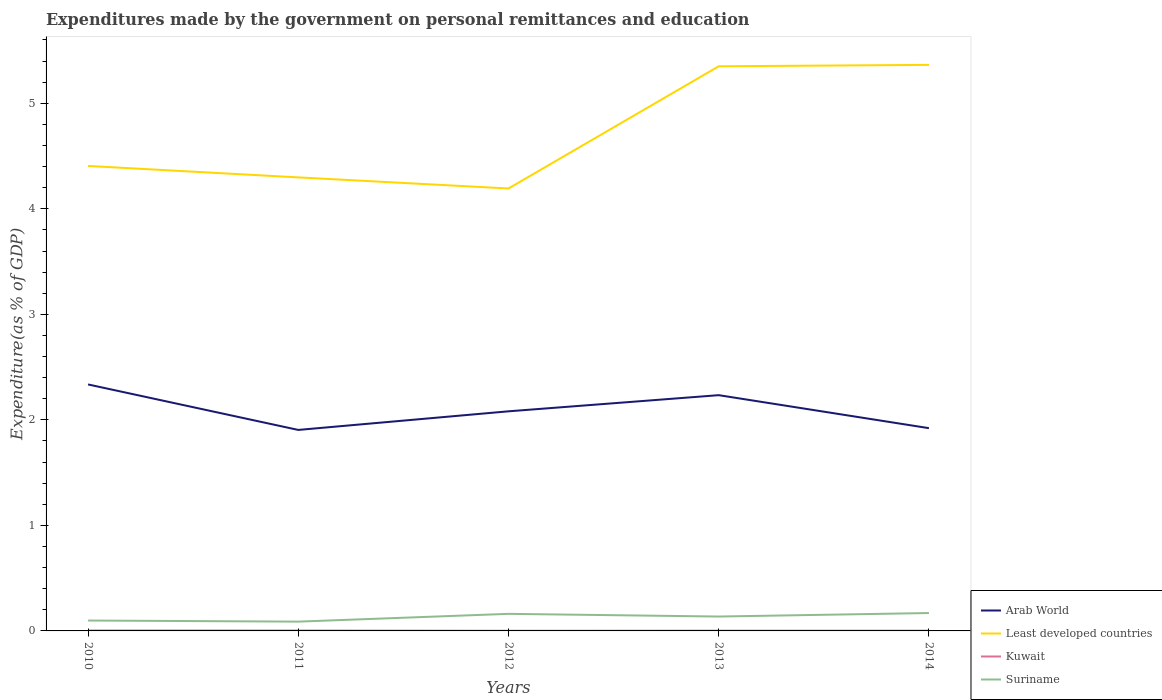How many different coloured lines are there?
Provide a short and direct response. 4. Is the number of lines equal to the number of legend labels?
Give a very brief answer. Yes. Across all years, what is the maximum expenditures made by the government on personal remittances and education in Arab World?
Keep it short and to the point. 1.9. In which year was the expenditures made by the government on personal remittances and education in Least developed countries maximum?
Provide a short and direct response. 2012. What is the total expenditures made by the government on personal remittances and education in Suriname in the graph?
Your response must be concise. -0.07. What is the difference between the highest and the second highest expenditures made by the government on personal remittances and education in Kuwait?
Your answer should be very brief. 0. What is the difference between the highest and the lowest expenditures made by the government on personal remittances and education in Kuwait?
Offer a very short reply. 2. Is the expenditures made by the government on personal remittances and education in Suriname strictly greater than the expenditures made by the government on personal remittances and education in Kuwait over the years?
Make the answer very short. No. What is the difference between two consecutive major ticks on the Y-axis?
Provide a short and direct response. 1. How are the legend labels stacked?
Offer a very short reply. Vertical. What is the title of the graph?
Provide a succinct answer. Expenditures made by the government on personal remittances and education. What is the label or title of the X-axis?
Your answer should be very brief. Years. What is the label or title of the Y-axis?
Your response must be concise. Expenditure(as % of GDP). What is the Expenditure(as % of GDP) of Arab World in 2010?
Offer a terse response. 2.34. What is the Expenditure(as % of GDP) of Least developed countries in 2010?
Your answer should be compact. 4.41. What is the Expenditure(as % of GDP) in Kuwait in 2010?
Your answer should be compact. 0. What is the Expenditure(as % of GDP) of Suriname in 2010?
Provide a succinct answer. 0.1. What is the Expenditure(as % of GDP) in Arab World in 2011?
Provide a short and direct response. 1.9. What is the Expenditure(as % of GDP) in Least developed countries in 2011?
Ensure brevity in your answer.  4.3. What is the Expenditure(as % of GDP) of Kuwait in 2011?
Your response must be concise. 0. What is the Expenditure(as % of GDP) in Suriname in 2011?
Give a very brief answer. 0.09. What is the Expenditure(as % of GDP) of Arab World in 2012?
Ensure brevity in your answer.  2.08. What is the Expenditure(as % of GDP) in Least developed countries in 2012?
Your response must be concise. 4.19. What is the Expenditure(as % of GDP) of Kuwait in 2012?
Make the answer very short. 0. What is the Expenditure(as % of GDP) in Suriname in 2012?
Give a very brief answer. 0.16. What is the Expenditure(as % of GDP) of Arab World in 2013?
Your response must be concise. 2.23. What is the Expenditure(as % of GDP) in Least developed countries in 2013?
Your answer should be compact. 5.35. What is the Expenditure(as % of GDP) in Kuwait in 2013?
Keep it short and to the point. 0. What is the Expenditure(as % of GDP) in Suriname in 2013?
Ensure brevity in your answer.  0.14. What is the Expenditure(as % of GDP) of Arab World in 2014?
Make the answer very short. 1.92. What is the Expenditure(as % of GDP) in Least developed countries in 2014?
Give a very brief answer. 5.36. What is the Expenditure(as % of GDP) of Kuwait in 2014?
Your answer should be very brief. 0. What is the Expenditure(as % of GDP) of Suriname in 2014?
Your answer should be compact. 0.17. Across all years, what is the maximum Expenditure(as % of GDP) of Arab World?
Your response must be concise. 2.34. Across all years, what is the maximum Expenditure(as % of GDP) in Least developed countries?
Ensure brevity in your answer.  5.36. Across all years, what is the maximum Expenditure(as % of GDP) of Kuwait?
Your answer should be compact. 0. Across all years, what is the maximum Expenditure(as % of GDP) of Suriname?
Your response must be concise. 0.17. Across all years, what is the minimum Expenditure(as % of GDP) in Arab World?
Your answer should be very brief. 1.9. Across all years, what is the minimum Expenditure(as % of GDP) in Least developed countries?
Keep it short and to the point. 4.19. Across all years, what is the minimum Expenditure(as % of GDP) in Kuwait?
Offer a terse response. 0. Across all years, what is the minimum Expenditure(as % of GDP) of Suriname?
Keep it short and to the point. 0.09. What is the total Expenditure(as % of GDP) of Arab World in the graph?
Give a very brief answer. 10.48. What is the total Expenditure(as % of GDP) in Least developed countries in the graph?
Give a very brief answer. 23.61. What is the total Expenditure(as % of GDP) in Kuwait in the graph?
Your response must be concise. 0.01. What is the total Expenditure(as % of GDP) in Suriname in the graph?
Keep it short and to the point. 0.65. What is the difference between the Expenditure(as % of GDP) of Arab World in 2010 and that in 2011?
Ensure brevity in your answer.  0.43. What is the difference between the Expenditure(as % of GDP) of Least developed countries in 2010 and that in 2011?
Make the answer very short. 0.11. What is the difference between the Expenditure(as % of GDP) in Suriname in 2010 and that in 2011?
Ensure brevity in your answer.  0.01. What is the difference between the Expenditure(as % of GDP) of Arab World in 2010 and that in 2012?
Provide a succinct answer. 0.25. What is the difference between the Expenditure(as % of GDP) in Least developed countries in 2010 and that in 2012?
Keep it short and to the point. 0.21. What is the difference between the Expenditure(as % of GDP) of Kuwait in 2010 and that in 2012?
Offer a terse response. 0. What is the difference between the Expenditure(as % of GDP) of Suriname in 2010 and that in 2012?
Provide a succinct answer. -0.06. What is the difference between the Expenditure(as % of GDP) of Arab World in 2010 and that in 2013?
Offer a terse response. 0.1. What is the difference between the Expenditure(as % of GDP) of Least developed countries in 2010 and that in 2013?
Keep it short and to the point. -0.94. What is the difference between the Expenditure(as % of GDP) in Kuwait in 2010 and that in 2013?
Your answer should be compact. 0. What is the difference between the Expenditure(as % of GDP) in Suriname in 2010 and that in 2013?
Keep it short and to the point. -0.04. What is the difference between the Expenditure(as % of GDP) in Arab World in 2010 and that in 2014?
Give a very brief answer. 0.41. What is the difference between the Expenditure(as % of GDP) of Least developed countries in 2010 and that in 2014?
Ensure brevity in your answer.  -0.96. What is the difference between the Expenditure(as % of GDP) of Kuwait in 2010 and that in 2014?
Provide a short and direct response. 0. What is the difference between the Expenditure(as % of GDP) of Suriname in 2010 and that in 2014?
Provide a succinct answer. -0.07. What is the difference between the Expenditure(as % of GDP) of Arab World in 2011 and that in 2012?
Offer a very short reply. -0.18. What is the difference between the Expenditure(as % of GDP) of Least developed countries in 2011 and that in 2012?
Provide a short and direct response. 0.1. What is the difference between the Expenditure(as % of GDP) of Kuwait in 2011 and that in 2012?
Ensure brevity in your answer.  0. What is the difference between the Expenditure(as % of GDP) of Suriname in 2011 and that in 2012?
Keep it short and to the point. -0.07. What is the difference between the Expenditure(as % of GDP) of Arab World in 2011 and that in 2013?
Make the answer very short. -0.33. What is the difference between the Expenditure(as % of GDP) in Least developed countries in 2011 and that in 2013?
Your response must be concise. -1.05. What is the difference between the Expenditure(as % of GDP) in Kuwait in 2011 and that in 2013?
Give a very brief answer. 0. What is the difference between the Expenditure(as % of GDP) of Suriname in 2011 and that in 2013?
Your answer should be compact. -0.05. What is the difference between the Expenditure(as % of GDP) in Arab World in 2011 and that in 2014?
Your answer should be very brief. -0.02. What is the difference between the Expenditure(as % of GDP) of Least developed countries in 2011 and that in 2014?
Your answer should be compact. -1.07. What is the difference between the Expenditure(as % of GDP) of Kuwait in 2011 and that in 2014?
Offer a very short reply. 0. What is the difference between the Expenditure(as % of GDP) in Suriname in 2011 and that in 2014?
Make the answer very short. -0.08. What is the difference between the Expenditure(as % of GDP) in Arab World in 2012 and that in 2013?
Give a very brief answer. -0.15. What is the difference between the Expenditure(as % of GDP) of Least developed countries in 2012 and that in 2013?
Offer a terse response. -1.16. What is the difference between the Expenditure(as % of GDP) in Kuwait in 2012 and that in 2013?
Provide a succinct answer. -0. What is the difference between the Expenditure(as % of GDP) of Suriname in 2012 and that in 2013?
Ensure brevity in your answer.  0.03. What is the difference between the Expenditure(as % of GDP) in Arab World in 2012 and that in 2014?
Your response must be concise. 0.16. What is the difference between the Expenditure(as % of GDP) of Least developed countries in 2012 and that in 2014?
Offer a very short reply. -1.17. What is the difference between the Expenditure(as % of GDP) in Kuwait in 2012 and that in 2014?
Offer a terse response. -0. What is the difference between the Expenditure(as % of GDP) in Suriname in 2012 and that in 2014?
Provide a short and direct response. -0.01. What is the difference between the Expenditure(as % of GDP) in Arab World in 2013 and that in 2014?
Your answer should be very brief. 0.31. What is the difference between the Expenditure(as % of GDP) in Least developed countries in 2013 and that in 2014?
Make the answer very short. -0.01. What is the difference between the Expenditure(as % of GDP) in Suriname in 2013 and that in 2014?
Your answer should be compact. -0.03. What is the difference between the Expenditure(as % of GDP) of Arab World in 2010 and the Expenditure(as % of GDP) of Least developed countries in 2011?
Provide a succinct answer. -1.96. What is the difference between the Expenditure(as % of GDP) of Arab World in 2010 and the Expenditure(as % of GDP) of Kuwait in 2011?
Your answer should be compact. 2.33. What is the difference between the Expenditure(as % of GDP) of Arab World in 2010 and the Expenditure(as % of GDP) of Suriname in 2011?
Offer a very short reply. 2.25. What is the difference between the Expenditure(as % of GDP) in Least developed countries in 2010 and the Expenditure(as % of GDP) in Kuwait in 2011?
Your response must be concise. 4.4. What is the difference between the Expenditure(as % of GDP) of Least developed countries in 2010 and the Expenditure(as % of GDP) of Suriname in 2011?
Offer a terse response. 4.32. What is the difference between the Expenditure(as % of GDP) in Kuwait in 2010 and the Expenditure(as % of GDP) in Suriname in 2011?
Keep it short and to the point. -0.08. What is the difference between the Expenditure(as % of GDP) in Arab World in 2010 and the Expenditure(as % of GDP) in Least developed countries in 2012?
Provide a succinct answer. -1.86. What is the difference between the Expenditure(as % of GDP) in Arab World in 2010 and the Expenditure(as % of GDP) in Kuwait in 2012?
Give a very brief answer. 2.33. What is the difference between the Expenditure(as % of GDP) in Arab World in 2010 and the Expenditure(as % of GDP) in Suriname in 2012?
Offer a very short reply. 2.17. What is the difference between the Expenditure(as % of GDP) of Least developed countries in 2010 and the Expenditure(as % of GDP) of Kuwait in 2012?
Give a very brief answer. 4.4. What is the difference between the Expenditure(as % of GDP) in Least developed countries in 2010 and the Expenditure(as % of GDP) in Suriname in 2012?
Provide a short and direct response. 4.24. What is the difference between the Expenditure(as % of GDP) in Kuwait in 2010 and the Expenditure(as % of GDP) in Suriname in 2012?
Make the answer very short. -0.16. What is the difference between the Expenditure(as % of GDP) of Arab World in 2010 and the Expenditure(as % of GDP) of Least developed countries in 2013?
Your answer should be compact. -3.01. What is the difference between the Expenditure(as % of GDP) in Arab World in 2010 and the Expenditure(as % of GDP) in Kuwait in 2013?
Make the answer very short. 2.33. What is the difference between the Expenditure(as % of GDP) in Arab World in 2010 and the Expenditure(as % of GDP) in Suriname in 2013?
Make the answer very short. 2.2. What is the difference between the Expenditure(as % of GDP) of Least developed countries in 2010 and the Expenditure(as % of GDP) of Kuwait in 2013?
Your answer should be very brief. 4.4. What is the difference between the Expenditure(as % of GDP) of Least developed countries in 2010 and the Expenditure(as % of GDP) of Suriname in 2013?
Ensure brevity in your answer.  4.27. What is the difference between the Expenditure(as % of GDP) of Kuwait in 2010 and the Expenditure(as % of GDP) of Suriname in 2013?
Your answer should be very brief. -0.13. What is the difference between the Expenditure(as % of GDP) of Arab World in 2010 and the Expenditure(as % of GDP) of Least developed countries in 2014?
Offer a terse response. -3.03. What is the difference between the Expenditure(as % of GDP) in Arab World in 2010 and the Expenditure(as % of GDP) in Kuwait in 2014?
Make the answer very short. 2.33. What is the difference between the Expenditure(as % of GDP) of Arab World in 2010 and the Expenditure(as % of GDP) of Suriname in 2014?
Keep it short and to the point. 2.17. What is the difference between the Expenditure(as % of GDP) in Least developed countries in 2010 and the Expenditure(as % of GDP) in Kuwait in 2014?
Offer a terse response. 4.4. What is the difference between the Expenditure(as % of GDP) in Least developed countries in 2010 and the Expenditure(as % of GDP) in Suriname in 2014?
Offer a very short reply. 4.24. What is the difference between the Expenditure(as % of GDP) in Kuwait in 2010 and the Expenditure(as % of GDP) in Suriname in 2014?
Make the answer very short. -0.17. What is the difference between the Expenditure(as % of GDP) in Arab World in 2011 and the Expenditure(as % of GDP) in Least developed countries in 2012?
Your answer should be compact. -2.29. What is the difference between the Expenditure(as % of GDP) of Arab World in 2011 and the Expenditure(as % of GDP) of Kuwait in 2012?
Ensure brevity in your answer.  1.9. What is the difference between the Expenditure(as % of GDP) of Arab World in 2011 and the Expenditure(as % of GDP) of Suriname in 2012?
Ensure brevity in your answer.  1.74. What is the difference between the Expenditure(as % of GDP) of Least developed countries in 2011 and the Expenditure(as % of GDP) of Kuwait in 2012?
Your answer should be compact. 4.3. What is the difference between the Expenditure(as % of GDP) of Least developed countries in 2011 and the Expenditure(as % of GDP) of Suriname in 2012?
Your response must be concise. 4.14. What is the difference between the Expenditure(as % of GDP) of Kuwait in 2011 and the Expenditure(as % of GDP) of Suriname in 2012?
Your answer should be compact. -0.16. What is the difference between the Expenditure(as % of GDP) in Arab World in 2011 and the Expenditure(as % of GDP) in Least developed countries in 2013?
Make the answer very short. -3.45. What is the difference between the Expenditure(as % of GDP) of Arab World in 2011 and the Expenditure(as % of GDP) of Kuwait in 2013?
Ensure brevity in your answer.  1.9. What is the difference between the Expenditure(as % of GDP) of Arab World in 2011 and the Expenditure(as % of GDP) of Suriname in 2013?
Provide a succinct answer. 1.77. What is the difference between the Expenditure(as % of GDP) in Least developed countries in 2011 and the Expenditure(as % of GDP) in Kuwait in 2013?
Ensure brevity in your answer.  4.3. What is the difference between the Expenditure(as % of GDP) of Least developed countries in 2011 and the Expenditure(as % of GDP) of Suriname in 2013?
Provide a succinct answer. 4.16. What is the difference between the Expenditure(as % of GDP) of Kuwait in 2011 and the Expenditure(as % of GDP) of Suriname in 2013?
Your answer should be compact. -0.13. What is the difference between the Expenditure(as % of GDP) of Arab World in 2011 and the Expenditure(as % of GDP) of Least developed countries in 2014?
Your answer should be very brief. -3.46. What is the difference between the Expenditure(as % of GDP) of Arab World in 2011 and the Expenditure(as % of GDP) of Kuwait in 2014?
Provide a short and direct response. 1.9. What is the difference between the Expenditure(as % of GDP) in Arab World in 2011 and the Expenditure(as % of GDP) in Suriname in 2014?
Provide a short and direct response. 1.74. What is the difference between the Expenditure(as % of GDP) in Least developed countries in 2011 and the Expenditure(as % of GDP) in Kuwait in 2014?
Ensure brevity in your answer.  4.3. What is the difference between the Expenditure(as % of GDP) of Least developed countries in 2011 and the Expenditure(as % of GDP) of Suriname in 2014?
Provide a short and direct response. 4.13. What is the difference between the Expenditure(as % of GDP) of Kuwait in 2011 and the Expenditure(as % of GDP) of Suriname in 2014?
Offer a very short reply. -0.17. What is the difference between the Expenditure(as % of GDP) of Arab World in 2012 and the Expenditure(as % of GDP) of Least developed countries in 2013?
Offer a very short reply. -3.27. What is the difference between the Expenditure(as % of GDP) in Arab World in 2012 and the Expenditure(as % of GDP) in Kuwait in 2013?
Make the answer very short. 2.08. What is the difference between the Expenditure(as % of GDP) of Arab World in 2012 and the Expenditure(as % of GDP) of Suriname in 2013?
Make the answer very short. 1.94. What is the difference between the Expenditure(as % of GDP) in Least developed countries in 2012 and the Expenditure(as % of GDP) in Kuwait in 2013?
Make the answer very short. 4.19. What is the difference between the Expenditure(as % of GDP) of Least developed countries in 2012 and the Expenditure(as % of GDP) of Suriname in 2013?
Your response must be concise. 4.06. What is the difference between the Expenditure(as % of GDP) of Kuwait in 2012 and the Expenditure(as % of GDP) of Suriname in 2013?
Provide a short and direct response. -0.13. What is the difference between the Expenditure(as % of GDP) of Arab World in 2012 and the Expenditure(as % of GDP) of Least developed countries in 2014?
Make the answer very short. -3.28. What is the difference between the Expenditure(as % of GDP) in Arab World in 2012 and the Expenditure(as % of GDP) in Kuwait in 2014?
Keep it short and to the point. 2.08. What is the difference between the Expenditure(as % of GDP) of Arab World in 2012 and the Expenditure(as % of GDP) of Suriname in 2014?
Your answer should be very brief. 1.91. What is the difference between the Expenditure(as % of GDP) of Least developed countries in 2012 and the Expenditure(as % of GDP) of Kuwait in 2014?
Provide a succinct answer. 4.19. What is the difference between the Expenditure(as % of GDP) of Least developed countries in 2012 and the Expenditure(as % of GDP) of Suriname in 2014?
Your answer should be very brief. 4.02. What is the difference between the Expenditure(as % of GDP) in Kuwait in 2012 and the Expenditure(as % of GDP) in Suriname in 2014?
Keep it short and to the point. -0.17. What is the difference between the Expenditure(as % of GDP) of Arab World in 2013 and the Expenditure(as % of GDP) of Least developed countries in 2014?
Ensure brevity in your answer.  -3.13. What is the difference between the Expenditure(as % of GDP) of Arab World in 2013 and the Expenditure(as % of GDP) of Kuwait in 2014?
Provide a short and direct response. 2.23. What is the difference between the Expenditure(as % of GDP) in Arab World in 2013 and the Expenditure(as % of GDP) in Suriname in 2014?
Keep it short and to the point. 2.06. What is the difference between the Expenditure(as % of GDP) of Least developed countries in 2013 and the Expenditure(as % of GDP) of Kuwait in 2014?
Your answer should be very brief. 5.35. What is the difference between the Expenditure(as % of GDP) in Least developed countries in 2013 and the Expenditure(as % of GDP) in Suriname in 2014?
Keep it short and to the point. 5.18. What is the difference between the Expenditure(as % of GDP) of Kuwait in 2013 and the Expenditure(as % of GDP) of Suriname in 2014?
Your answer should be compact. -0.17. What is the average Expenditure(as % of GDP) in Arab World per year?
Provide a short and direct response. 2.1. What is the average Expenditure(as % of GDP) of Least developed countries per year?
Offer a very short reply. 4.72. What is the average Expenditure(as % of GDP) in Kuwait per year?
Keep it short and to the point. 0. What is the average Expenditure(as % of GDP) of Suriname per year?
Provide a succinct answer. 0.13. In the year 2010, what is the difference between the Expenditure(as % of GDP) in Arab World and Expenditure(as % of GDP) in Least developed countries?
Keep it short and to the point. -2.07. In the year 2010, what is the difference between the Expenditure(as % of GDP) in Arab World and Expenditure(as % of GDP) in Kuwait?
Make the answer very short. 2.33. In the year 2010, what is the difference between the Expenditure(as % of GDP) in Arab World and Expenditure(as % of GDP) in Suriname?
Ensure brevity in your answer.  2.24. In the year 2010, what is the difference between the Expenditure(as % of GDP) in Least developed countries and Expenditure(as % of GDP) in Kuwait?
Provide a succinct answer. 4.4. In the year 2010, what is the difference between the Expenditure(as % of GDP) in Least developed countries and Expenditure(as % of GDP) in Suriname?
Your answer should be very brief. 4.31. In the year 2010, what is the difference between the Expenditure(as % of GDP) in Kuwait and Expenditure(as % of GDP) in Suriname?
Give a very brief answer. -0.09. In the year 2011, what is the difference between the Expenditure(as % of GDP) in Arab World and Expenditure(as % of GDP) in Least developed countries?
Your response must be concise. -2.39. In the year 2011, what is the difference between the Expenditure(as % of GDP) in Arab World and Expenditure(as % of GDP) in Kuwait?
Provide a succinct answer. 1.9. In the year 2011, what is the difference between the Expenditure(as % of GDP) in Arab World and Expenditure(as % of GDP) in Suriname?
Give a very brief answer. 1.82. In the year 2011, what is the difference between the Expenditure(as % of GDP) in Least developed countries and Expenditure(as % of GDP) in Kuwait?
Offer a very short reply. 4.29. In the year 2011, what is the difference between the Expenditure(as % of GDP) of Least developed countries and Expenditure(as % of GDP) of Suriname?
Ensure brevity in your answer.  4.21. In the year 2011, what is the difference between the Expenditure(as % of GDP) of Kuwait and Expenditure(as % of GDP) of Suriname?
Make the answer very short. -0.08. In the year 2012, what is the difference between the Expenditure(as % of GDP) in Arab World and Expenditure(as % of GDP) in Least developed countries?
Provide a succinct answer. -2.11. In the year 2012, what is the difference between the Expenditure(as % of GDP) of Arab World and Expenditure(as % of GDP) of Kuwait?
Your response must be concise. 2.08. In the year 2012, what is the difference between the Expenditure(as % of GDP) of Arab World and Expenditure(as % of GDP) of Suriname?
Offer a very short reply. 1.92. In the year 2012, what is the difference between the Expenditure(as % of GDP) of Least developed countries and Expenditure(as % of GDP) of Kuwait?
Ensure brevity in your answer.  4.19. In the year 2012, what is the difference between the Expenditure(as % of GDP) of Least developed countries and Expenditure(as % of GDP) of Suriname?
Provide a succinct answer. 4.03. In the year 2012, what is the difference between the Expenditure(as % of GDP) of Kuwait and Expenditure(as % of GDP) of Suriname?
Give a very brief answer. -0.16. In the year 2013, what is the difference between the Expenditure(as % of GDP) of Arab World and Expenditure(as % of GDP) of Least developed countries?
Make the answer very short. -3.12. In the year 2013, what is the difference between the Expenditure(as % of GDP) in Arab World and Expenditure(as % of GDP) in Kuwait?
Give a very brief answer. 2.23. In the year 2013, what is the difference between the Expenditure(as % of GDP) of Arab World and Expenditure(as % of GDP) of Suriname?
Give a very brief answer. 2.1. In the year 2013, what is the difference between the Expenditure(as % of GDP) in Least developed countries and Expenditure(as % of GDP) in Kuwait?
Ensure brevity in your answer.  5.35. In the year 2013, what is the difference between the Expenditure(as % of GDP) of Least developed countries and Expenditure(as % of GDP) of Suriname?
Ensure brevity in your answer.  5.21. In the year 2013, what is the difference between the Expenditure(as % of GDP) of Kuwait and Expenditure(as % of GDP) of Suriname?
Offer a terse response. -0.13. In the year 2014, what is the difference between the Expenditure(as % of GDP) in Arab World and Expenditure(as % of GDP) in Least developed countries?
Provide a short and direct response. -3.44. In the year 2014, what is the difference between the Expenditure(as % of GDP) in Arab World and Expenditure(as % of GDP) in Kuwait?
Your answer should be very brief. 1.92. In the year 2014, what is the difference between the Expenditure(as % of GDP) of Arab World and Expenditure(as % of GDP) of Suriname?
Your answer should be compact. 1.75. In the year 2014, what is the difference between the Expenditure(as % of GDP) in Least developed countries and Expenditure(as % of GDP) in Kuwait?
Keep it short and to the point. 5.36. In the year 2014, what is the difference between the Expenditure(as % of GDP) of Least developed countries and Expenditure(as % of GDP) of Suriname?
Ensure brevity in your answer.  5.19. In the year 2014, what is the difference between the Expenditure(as % of GDP) in Kuwait and Expenditure(as % of GDP) in Suriname?
Offer a very short reply. -0.17. What is the ratio of the Expenditure(as % of GDP) in Arab World in 2010 to that in 2011?
Your response must be concise. 1.23. What is the ratio of the Expenditure(as % of GDP) of Least developed countries in 2010 to that in 2011?
Your answer should be very brief. 1.03. What is the ratio of the Expenditure(as % of GDP) in Kuwait in 2010 to that in 2011?
Provide a succinct answer. 1.14. What is the ratio of the Expenditure(as % of GDP) in Suriname in 2010 to that in 2011?
Give a very brief answer. 1.12. What is the ratio of the Expenditure(as % of GDP) in Arab World in 2010 to that in 2012?
Your answer should be very brief. 1.12. What is the ratio of the Expenditure(as % of GDP) of Least developed countries in 2010 to that in 2012?
Offer a very short reply. 1.05. What is the ratio of the Expenditure(as % of GDP) in Kuwait in 2010 to that in 2012?
Your response must be concise. 2.77. What is the ratio of the Expenditure(as % of GDP) of Suriname in 2010 to that in 2012?
Your answer should be compact. 0.61. What is the ratio of the Expenditure(as % of GDP) of Arab World in 2010 to that in 2013?
Offer a terse response. 1.05. What is the ratio of the Expenditure(as % of GDP) in Least developed countries in 2010 to that in 2013?
Your answer should be very brief. 0.82. What is the ratio of the Expenditure(as % of GDP) of Kuwait in 2010 to that in 2013?
Your answer should be compact. 1.72. What is the ratio of the Expenditure(as % of GDP) in Suriname in 2010 to that in 2013?
Ensure brevity in your answer.  0.72. What is the ratio of the Expenditure(as % of GDP) of Arab World in 2010 to that in 2014?
Give a very brief answer. 1.22. What is the ratio of the Expenditure(as % of GDP) of Least developed countries in 2010 to that in 2014?
Your response must be concise. 0.82. What is the ratio of the Expenditure(as % of GDP) of Kuwait in 2010 to that in 2014?
Your answer should be very brief. 1.78. What is the ratio of the Expenditure(as % of GDP) in Suriname in 2010 to that in 2014?
Make the answer very short. 0.58. What is the ratio of the Expenditure(as % of GDP) in Arab World in 2011 to that in 2012?
Provide a succinct answer. 0.92. What is the ratio of the Expenditure(as % of GDP) in Least developed countries in 2011 to that in 2012?
Your response must be concise. 1.03. What is the ratio of the Expenditure(as % of GDP) in Kuwait in 2011 to that in 2012?
Offer a very short reply. 2.44. What is the ratio of the Expenditure(as % of GDP) in Suriname in 2011 to that in 2012?
Offer a terse response. 0.54. What is the ratio of the Expenditure(as % of GDP) of Arab World in 2011 to that in 2013?
Ensure brevity in your answer.  0.85. What is the ratio of the Expenditure(as % of GDP) in Least developed countries in 2011 to that in 2013?
Provide a short and direct response. 0.8. What is the ratio of the Expenditure(as % of GDP) of Kuwait in 2011 to that in 2013?
Give a very brief answer. 1.51. What is the ratio of the Expenditure(as % of GDP) in Suriname in 2011 to that in 2013?
Make the answer very short. 0.65. What is the ratio of the Expenditure(as % of GDP) in Least developed countries in 2011 to that in 2014?
Offer a very short reply. 0.8. What is the ratio of the Expenditure(as % of GDP) of Kuwait in 2011 to that in 2014?
Ensure brevity in your answer.  1.56. What is the ratio of the Expenditure(as % of GDP) in Suriname in 2011 to that in 2014?
Your response must be concise. 0.52. What is the ratio of the Expenditure(as % of GDP) in Arab World in 2012 to that in 2013?
Your response must be concise. 0.93. What is the ratio of the Expenditure(as % of GDP) in Least developed countries in 2012 to that in 2013?
Ensure brevity in your answer.  0.78. What is the ratio of the Expenditure(as % of GDP) in Kuwait in 2012 to that in 2013?
Offer a terse response. 0.62. What is the ratio of the Expenditure(as % of GDP) of Suriname in 2012 to that in 2013?
Keep it short and to the point. 1.19. What is the ratio of the Expenditure(as % of GDP) of Arab World in 2012 to that in 2014?
Ensure brevity in your answer.  1.08. What is the ratio of the Expenditure(as % of GDP) of Least developed countries in 2012 to that in 2014?
Your answer should be compact. 0.78. What is the ratio of the Expenditure(as % of GDP) in Kuwait in 2012 to that in 2014?
Your answer should be compact. 0.64. What is the ratio of the Expenditure(as % of GDP) in Suriname in 2012 to that in 2014?
Provide a short and direct response. 0.95. What is the ratio of the Expenditure(as % of GDP) of Arab World in 2013 to that in 2014?
Make the answer very short. 1.16. What is the ratio of the Expenditure(as % of GDP) in Kuwait in 2013 to that in 2014?
Keep it short and to the point. 1.03. What is the ratio of the Expenditure(as % of GDP) in Suriname in 2013 to that in 2014?
Offer a very short reply. 0.8. What is the difference between the highest and the second highest Expenditure(as % of GDP) of Arab World?
Make the answer very short. 0.1. What is the difference between the highest and the second highest Expenditure(as % of GDP) in Least developed countries?
Your response must be concise. 0.01. What is the difference between the highest and the second highest Expenditure(as % of GDP) in Suriname?
Make the answer very short. 0.01. What is the difference between the highest and the lowest Expenditure(as % of GDP) in Arab World?
Your answer should be very brief. 0.43. What is the difference between the highest and the lowest Expenditure(as % of GDP) of Least developed countries?
Provide a succinct answer. 1.17. What is the difference between the highest and the lowest Expenditure(as % of GDP) in Kuwait?
Your answer should be very brief. 0. What is the difference between the highest and the lowest Expenditure(as % of GDP) in Suriname?
Give a very brief answer. 0.08. 